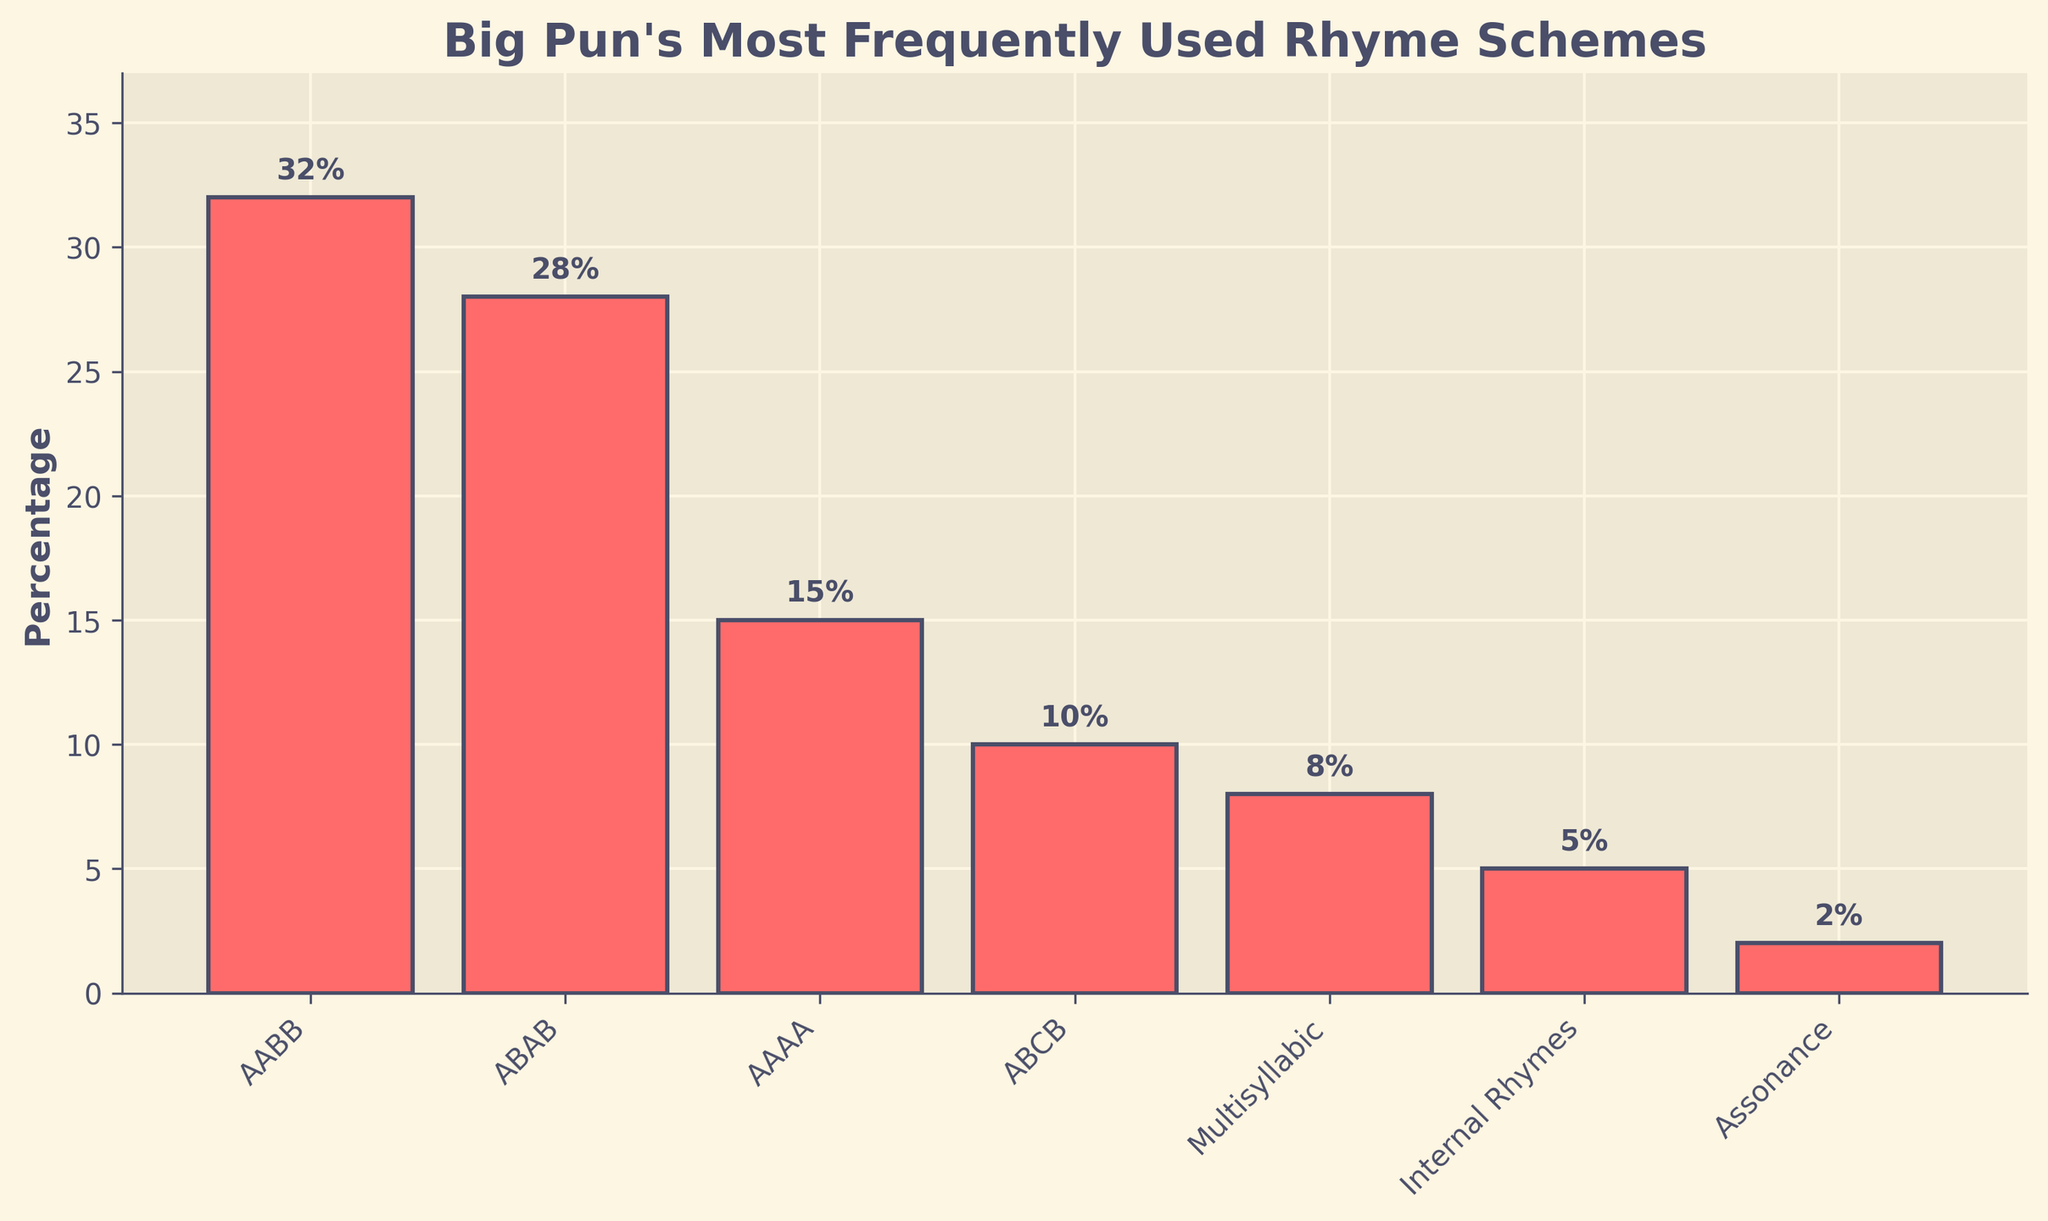Which rhyme scheme has the highest percentage usage in Big Pun's lyrics? The highest bar on the chart represents the most frequently used rhyme scheme. The tallest bar corresponds to the "AABB" rhyme scheme with a percentage of 32%.
Answer: AABB How does the percentage of the ABAB rhyme scheme compare to the Multisyllabic rhyme scheme? The height of the bars indicates the percentages. The ABAB rhyme scheme is represented by the second tallest bar at 28%, while the Multisyllabic rhyme scheme has a shorter bar at 8%.
Answer: ABAB is higher What’s the combined percentage of the AAAA and ABCB rhyme schemes? The combined percentage is found by adding the values for AAAA (15%) and ABCB (10%). So, 15% + 10% = 25%.
Answer: 25% Which rhyme schemes have percentages lower than 10%? Rhyme schemes with bars shorter than the 10% mark are considered. These schemes are Multisyllabic (8%), Internal Rhymes (5%), and Assonance (2%).
Answer: Multisyllabic, Internal Rhymes, Assonance What's the visual difference in bar heights between the ABCB and Assonance rhyme schemes? The height of the bars represents their percentages, with ABCB at 10% and Assonance at 2%. The difference in height corresponds to the difference in percentages, which is 10% - 2% = 8%.
Answer: 8% What percentage range contains the majority of rhyme schemes used by Big Pun? The majority of rhyme schemes fall between 0% and 32%. Analyzing the chart, most schemes appear between 0% and 15%.
Answer: 0% to 15% What’s the difference in percentage points between the most and least frequently used rhyme schemes? The AABB scheme, at 32%, is the most used, and the Assonance scheme, at 2%, is the least used. The difference is 32% - 2% = 30%.
Answer: 30% If you were to average the percentages of the top three rhyme schemes, what would it be? First, identify the top three: AABB (32%), ABAB (28%), and AAAA (15%). Sum these values and divide by 3: (32 + 28 + 15) / 3 = 25%.
Answer: 25% How much more frequently is the AABB rhyme scheme used compared to Internal Rhymes? AABB is at 32%. Internal Rhymes are at 5%. The difference in usage is 32% - 5% = 27%.
Answer: 27% What can you observe about the overall trend in rhyme scheme usage from the bar chart? The overall trend indicates that traditional rhyme schemes like AABB and ABAB are used overwhelmingly more than more complex schemes such as Assonance and Internal Rhymes, as shown by the decreasing heights of the bars from left to right.
Answer: Traditional schemes are more frequently used 